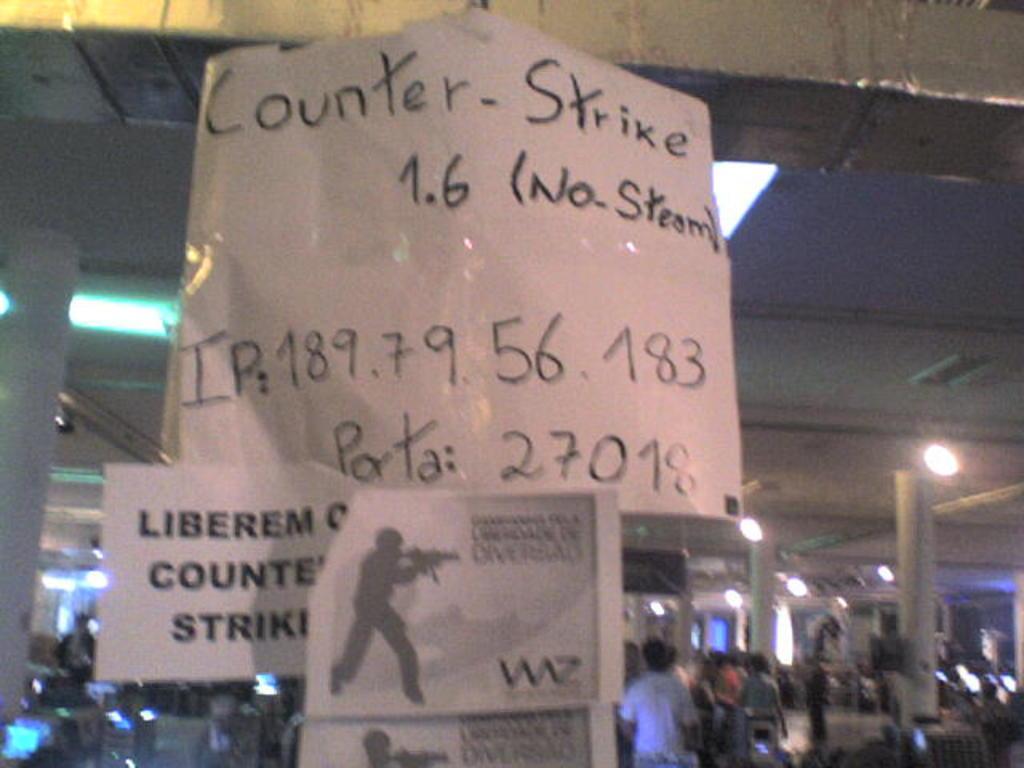Describe this image in one or two sentences. In this image, in the middle, we can see some papers, in the papers, we can see some text written on it. On the right side, we can see a group of people, pillars, lights and monitor. On the left side, we can also see a group of people, lights, pillars. At the top, we can see a roof with few lights. 